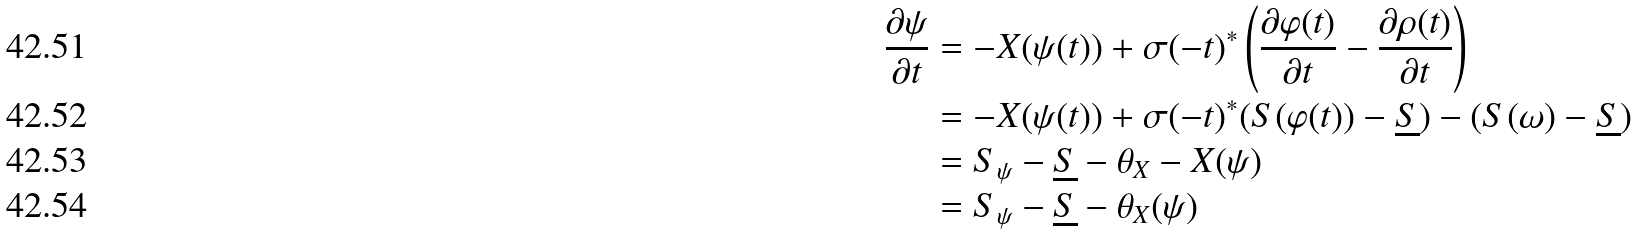Convert formula to latex. <formula><loc_0><loc_0><loc_500><loc_500>\frac { \partial \psi } { \partial t } & = - X ( \psi ( t ) ) + \sigma ( - t ) ^ { \ast } \left ( \frac { \partial \varphi ( t ) } { \partial t } - \frac { \partial \rho ( t ) } { \partial t } \right ) \\ & = - X ( \psi ( t ) ) + \sigma ( - t ) ^ { \ast } ( S ( \varphi ( t ) ) - \underline { S } ) - ( S ( \omega ) - \underline { S } ) \\ & = S _ { \psi } - \underline { S } - \theta _ { X } - X ( \psi ) \\ & = S _ { \psi } - \underline { S } - \theta _ { X } ( \psi )</formula> 